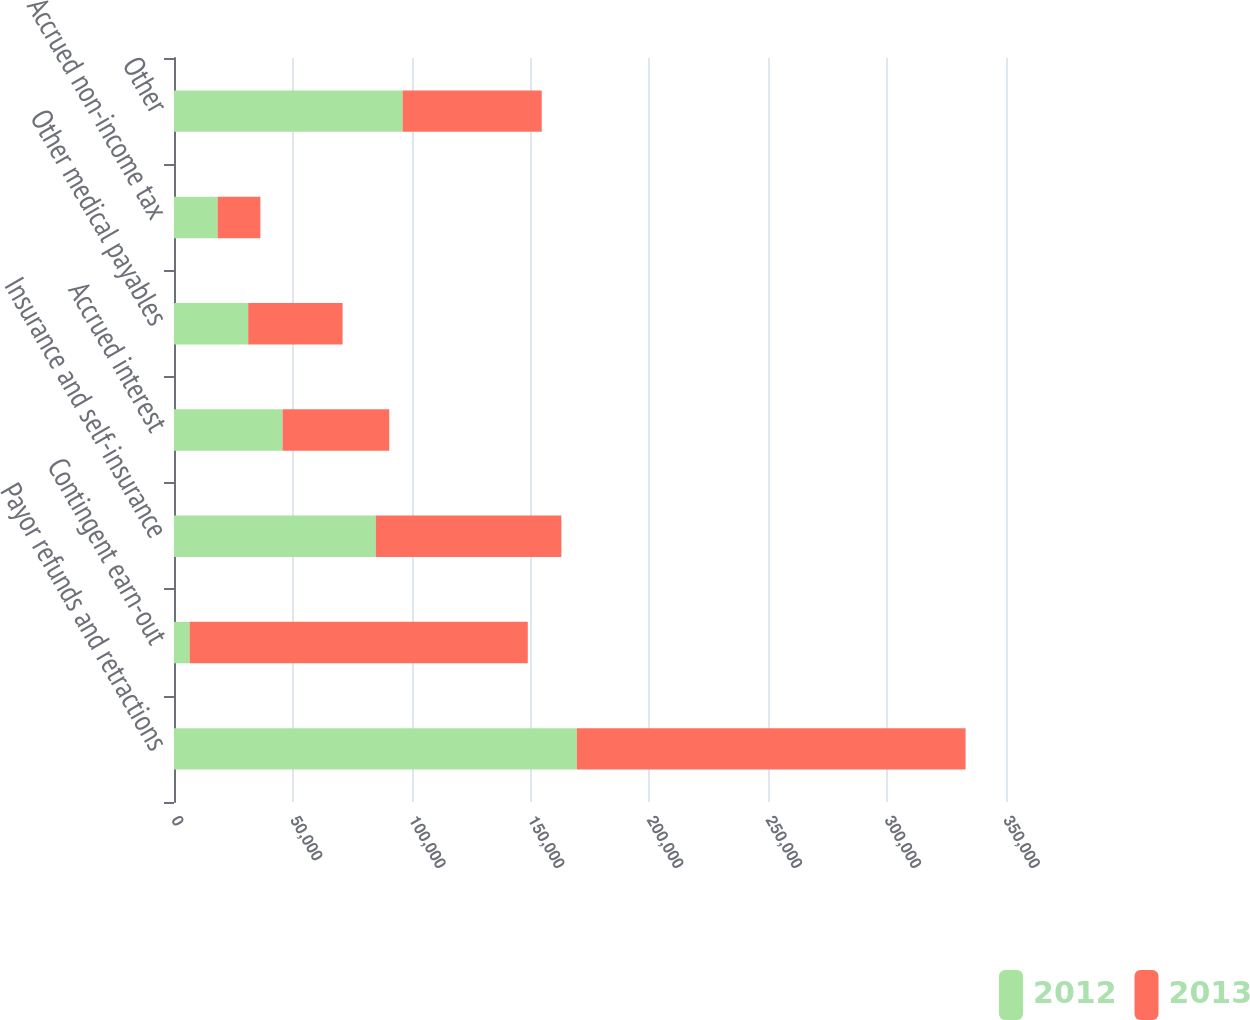Convert chart to OTSL. <chart><loc_0><loc_0><loc_500><loc_500><stacked_bar_chart><ecel><fcel>Payor refunds and retractions<fcel>Contingent earn-out<fcel>Insurance and self-insurance<fcel>Accrued interest<fcel>Other medical payables<fcel>Accrued non-income tax<fcel>Other<nl><fcel>2012<fcel>169480<fcel>6577<fcel>84882<fcel>45662<fcel>31219<fcel>18366<fcel>96167<nl><fcel>2013<fcel>163520<fcel>142244<fcel>78073<fcel>44884<fcel>39698<fcel>17976<fcel>58530<nl></chart> 